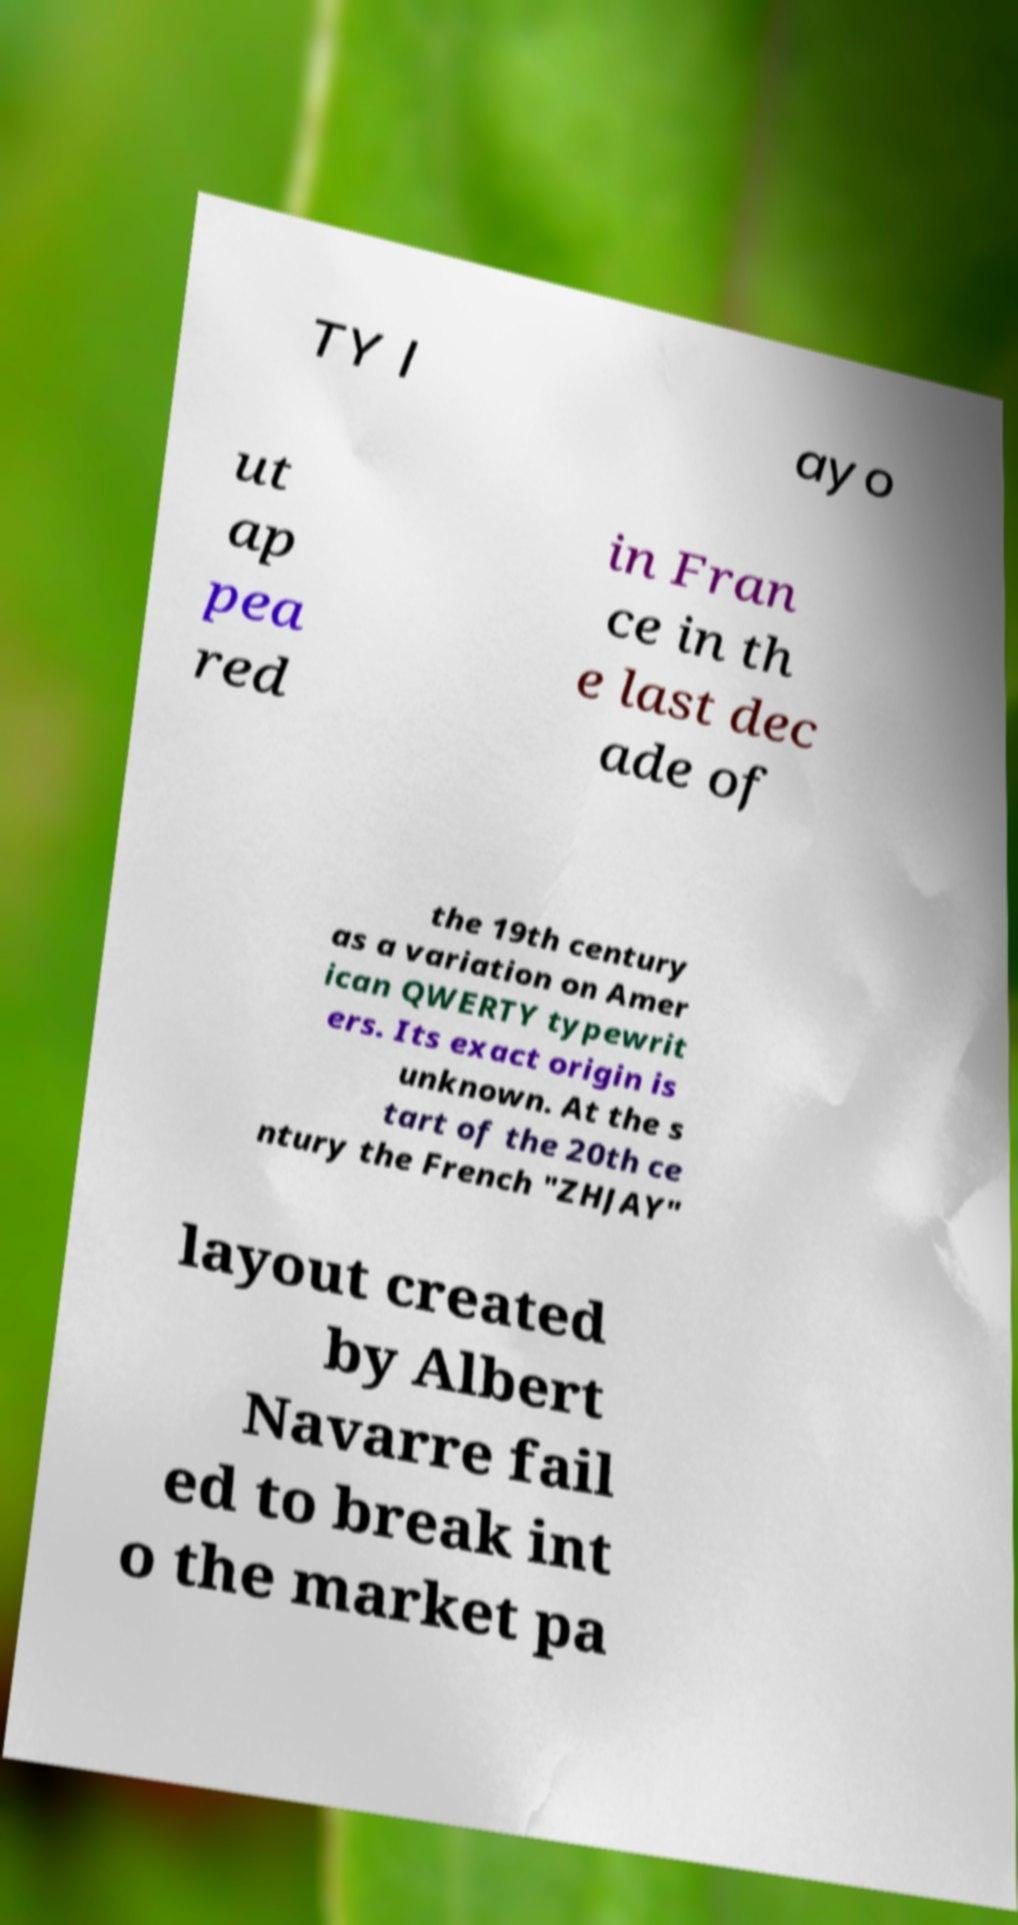Could you assist in decoding the text presented in this image and type it out clearly? TY l ayo ut ap pea red in Fran ce in th e last dec ade of the 19th century as a variation on Amer ican QWERTY typewrit ers. Its exact origin is unknown. At the s tart of the 20th ce ntury the French "ZHJAY" layout created by Albert Navarre fail ed to break int o the market pa 